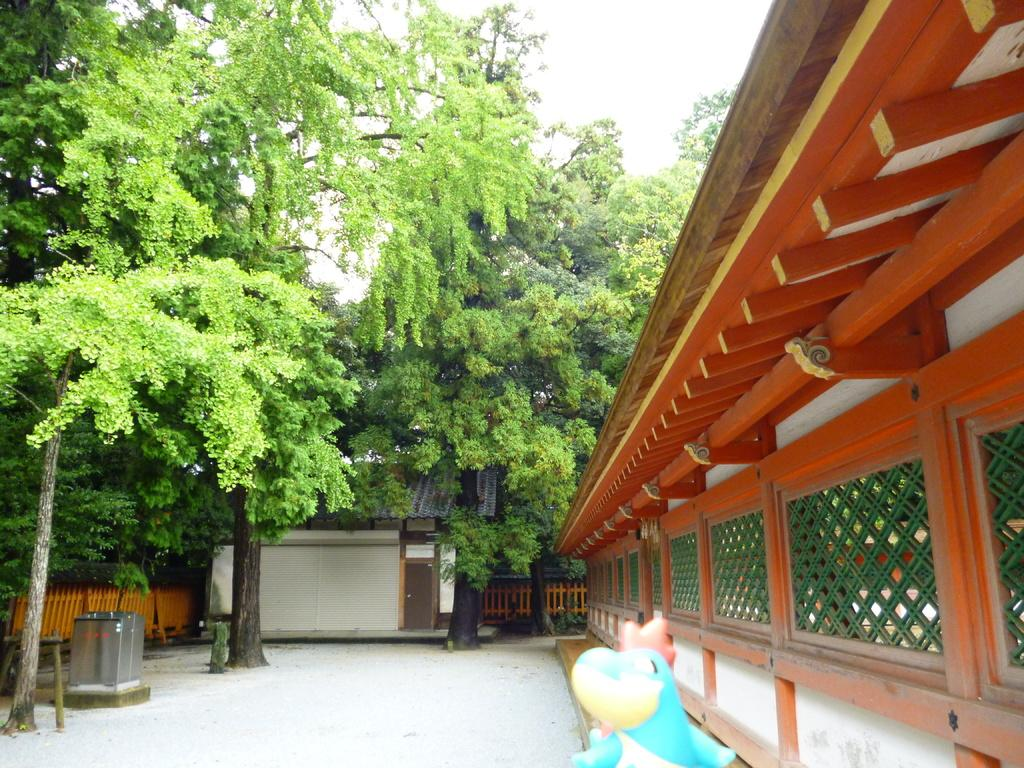What type of natural elements can be seen in the image? There are trees in the image. What type of man-made structures are present in the image? There are buildings in the image. What color is the object or area that stands out in the image? There is a blue-colored object or area in the image. How many seeds can be seen on the ground near the trees in the image? There is no mention of seeds in the image, so it is not possible to determine how many seeds might be present. 